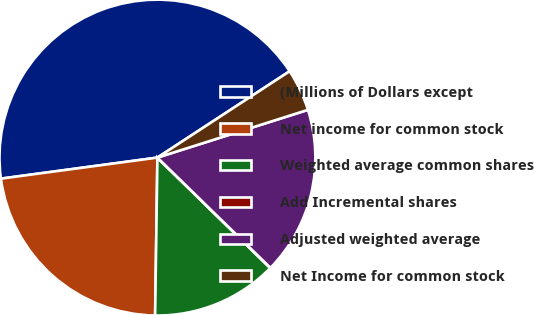Convert chart to OTSL. <chart><loc_0><loc_0><loc_500><loc_500><pie_chart><fcel>(Millions of Dollars except<fcel>Net income for common stock<fcel>Weighted average common shares<fcel>Add Incremental shares<fcel>Adjusted weighted average<fcel>Net Income for common stock<nl><fcel>42.92%<fcel>22.64%<fcel>12.9%<fcel>0.03%<fcel>17.19%<fcel>4.32%<nl></chart> 